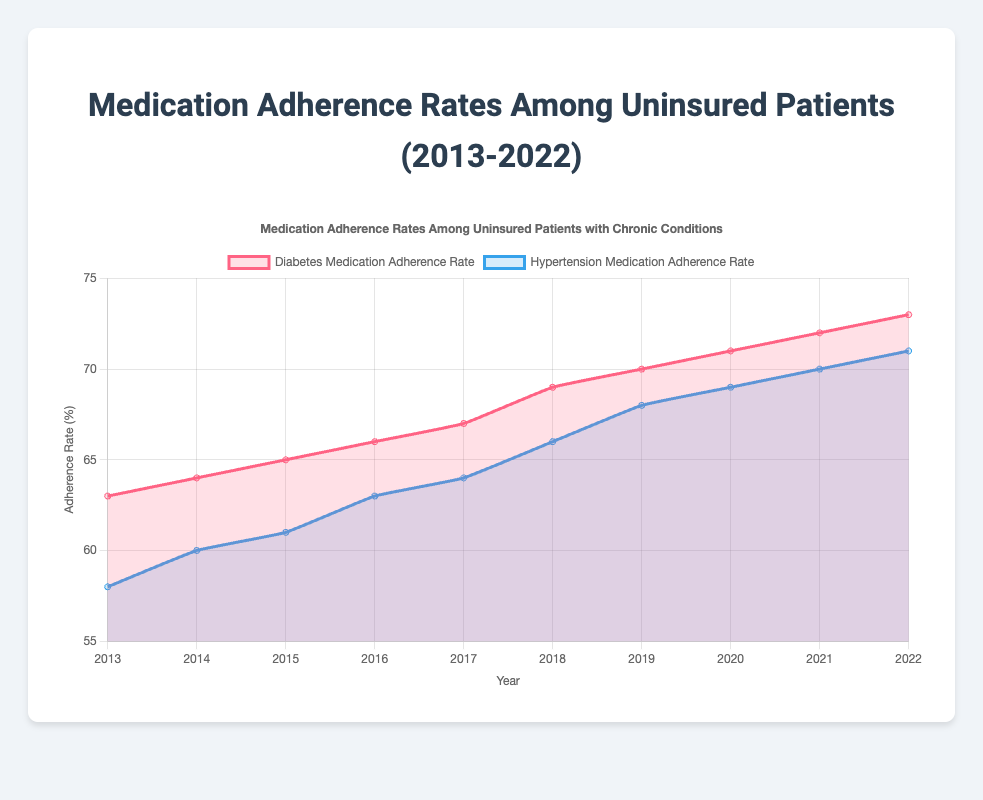What is the title of the chart? The title is usually displayed at the top of the chart. In this case, it is "Medication Adherence Rates Among Uninsured Patients (2013-2022)", as indicated in both the data and the provided code HTML heading.
Answer: Medication Adherence Rates Among Uninsured Patients (2013-2022) What does the y-axis represent? The label on the y-axis in the figure indicates that it represents "Adherence Rate (%)". The values range from 55 to 75 to align with the adherence rates data.
Answer: Adherence Rate (%) Which chronic condition had a higher medication adherence rate in 2015? To answer this question, refer to the data points for the year 2015. The Diabetes Medication Adherence Rate is 65%, and the Hypertension Medication Adherence Rate is 61%. Thus, the adherence rate for diabetes is higher.
Answer: Diabetes How did the medication adherence rates for diabetes and hypertension change from 2013 to 2022? From the data, the Diabetes Medication Adherence Rate increased from 63% in 2013 to 73% in 2022. Meanwhile, the Hypertension Medication Adherence Rate increased from 58% in 2013 to 71% in 2022.
Answer: Both increased In which year did the diabetes medication adherence rate equal the hypertension medication adherence rate of the following year? To solve this, check for a year when the diabetes adherence rate for that year matches the hypertension adherence rate of the subsequent year. In 2019, the diabetes rate is 70%, which is the rate for hypertension in 2020.
Answer: 2019 What is the average medication adherence rate for diabetes over the given years? Sum the adherence rates for diabetes from 2013 to 2022: 63 + 64 + 65 + 66 + 67 + 69 + 70 + 71 + 72 + 73 = 680. Divide this sum by the number of years (10). The average adherence rate is 680/10 = 68%.
Answer: 68% What is the overall trend in medication adherence rates among uninsured patients with chronic conditions? Both medication adherence rates for diabetes and hypertension show an upward trend over the last decade. This indicates an improvement in medication adherence among uninsured patients over this period.
Answer: Increasing Which year saw the highest rate of hypertension medication adherence? Review the data points for the Hypertension Medication Adherence Rate. The highest rate is 71%, and it occurs in the year 2022.
Answer: 2022 Compare the medication adherence rates for diabetes and hypertension in 2020. Which is higher? By looking at the data for 2020, the Diabetes Medication Adherence Rate is 71%, and the Hypertension Medication Adherence Rate is 69%. Thus, the adherence rate for diabetes is higher in 2020.
Answer: Diabetes Was there any year where the increase in adherence rate from the previous year was greater for hypertension compared to diabetes? Calculate the yearly increases for both conditions. In 2015, the Hypertension rate increased by 2% from the previous year (60% to 61%), while the Diabetes rate increased by 1% (64% to 65%). This pattern occurs only in 2015.
Answer: 2015 